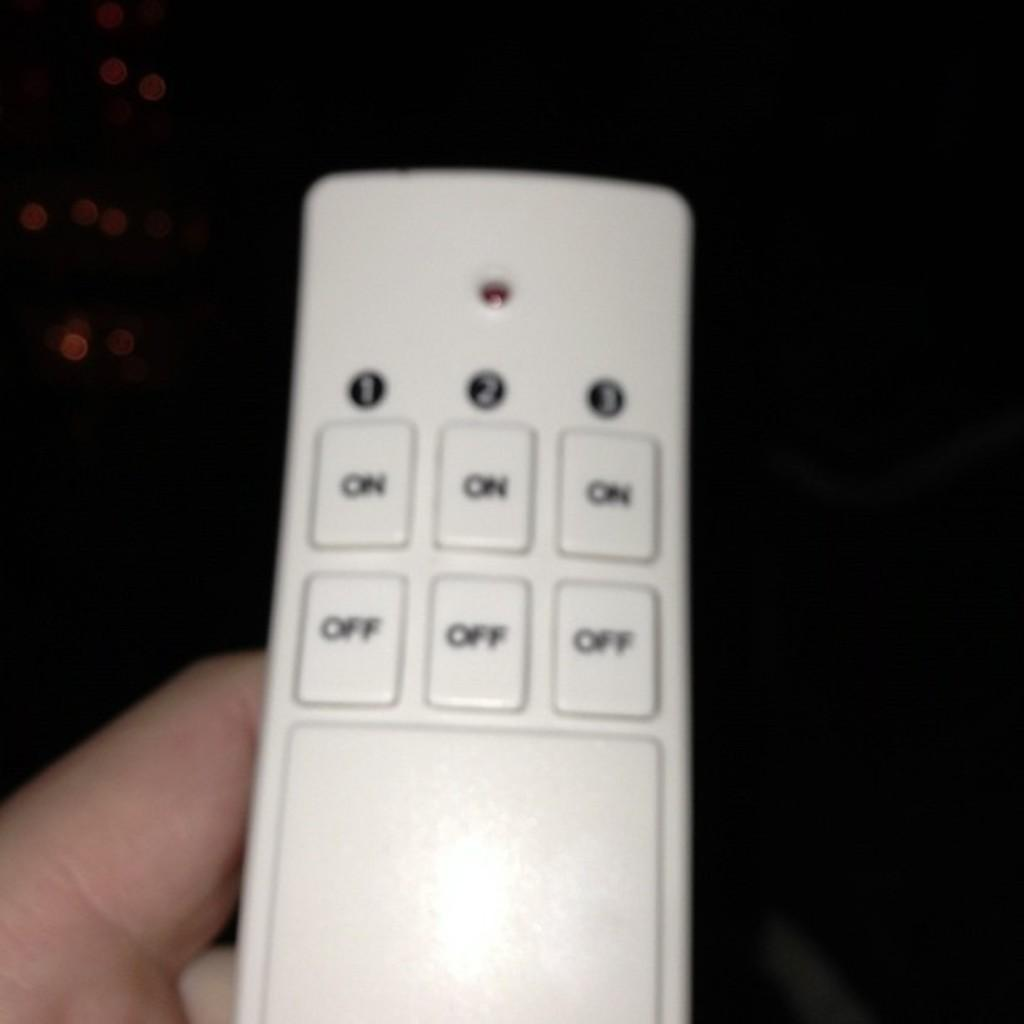<image>
Relay a brief, clear account of the picture shown. A white remote control has three ON buttons and three OFF buttons. 